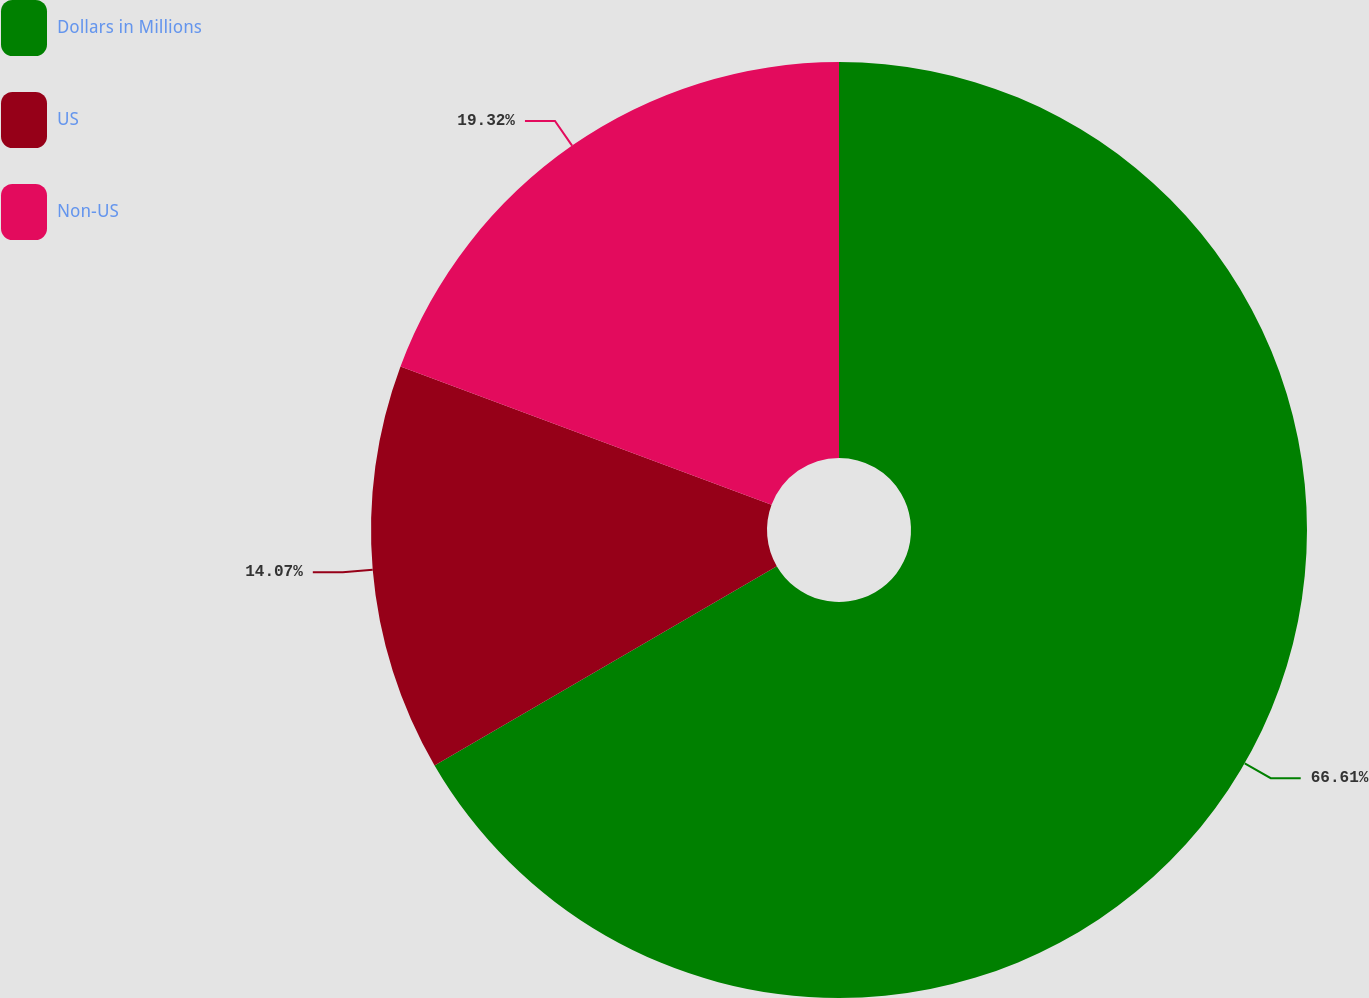Convert chart. <chart><loc_0><loc_0><loc_500><loc_500><pie_chart><fcel>Dollars in Millions<fcel>US<fcel>Non-US<nl><fcel>66.61%<fcel>14.07%<fcel>19.32%<nl></chart> 